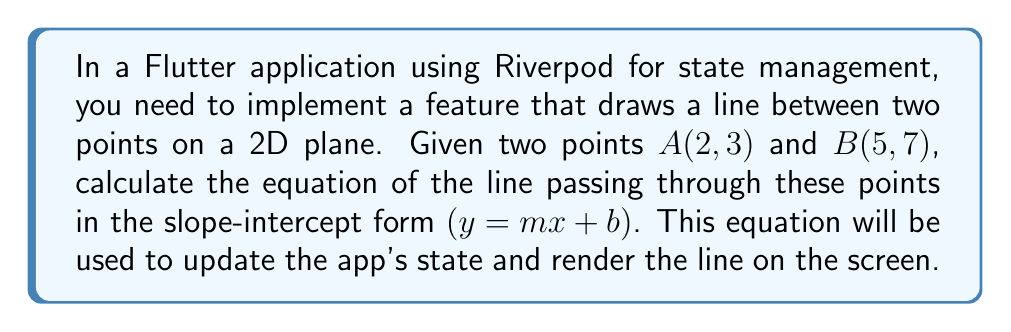Show me your answer to this math problem. Let's solve this step-by-step:

1) To find the equation of a line in slope-intercept form $(y = mx + b)$, we need to calculate the slope $(m)$ and y-intercept $(b)$.

2) First, let's calculate the slope $(m)$ using the slope formula:

   $$m = \frac{y_2 - y_1}{x_2 - x_1} = \frac{7 - 3}{5 - 2} = \frac{4}{3}$$

3) Now that we have the slope, we can use the point-slope form of a line equation:

   $$y - y_1 = m(x - x_1)$$

4) Let's use point $A(2, 3)$ and substitute our known values:

   $$y - 3 = \frac{4}{3}(x - 2)$$

5) Expand the right side of the equation:

   $$y - 3 = \frac{4}{3}x - \frac{8}{3}$$

6) Add 3 to both sides to isolate $y$:

   $$y = \frac{4}{3}x - \frac{8}{3} + 3$$

7) Simplify the right side:

   $$y = \frac{4}{3}x - \frac{8}{3} + \frac{9}{3} = \frac{4}{3}x + \frac{1}{3}$$

8) This is now in slope-intercept form $(y = mx + b)$, where $m = \frac{4}{3}$ and $b = \frac{1}{3}$.
Answer: $y = \frac{4}{3}x + \frac{1}{3}$ 